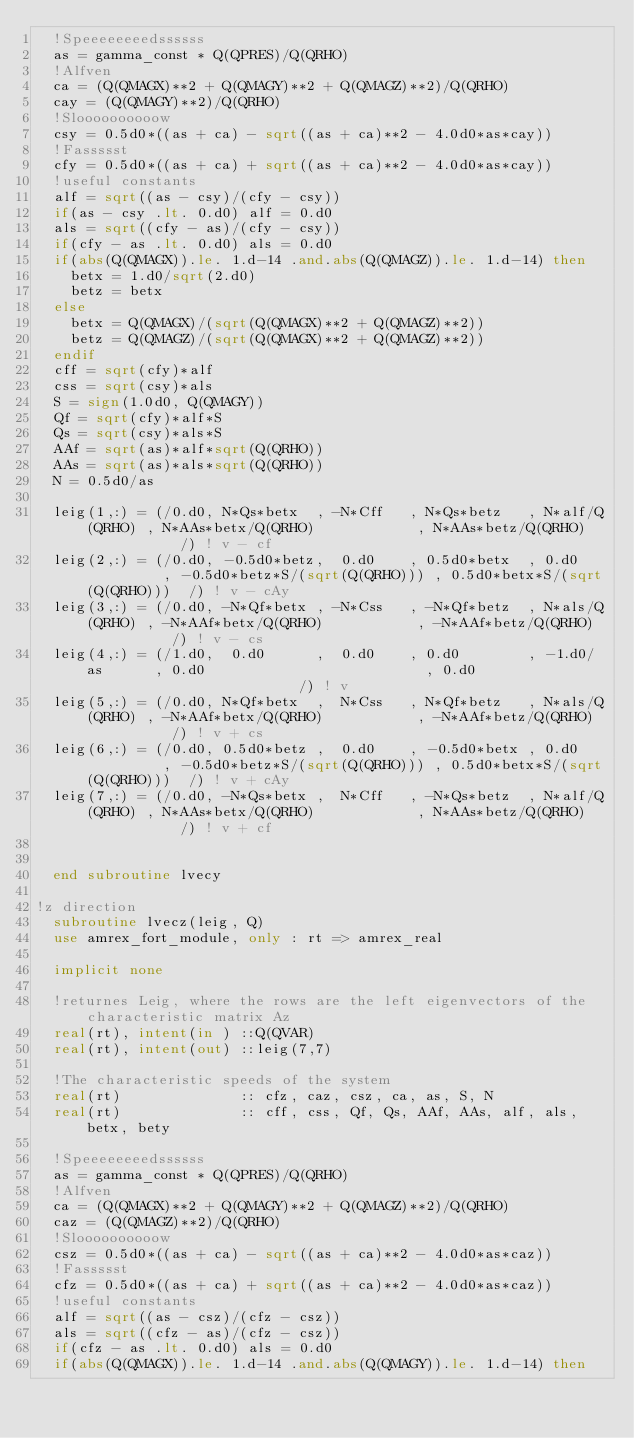Convert code to text. <code><loc_0><loc_0><loc_500><loc_500><_FORTRAN_>  !Speeeeeeeedssssss
  as = gamma_const * Q(QPRES)/Q(QRHO)
  !Alfven
  ca = (Q(QMAGX)**2 + Q(QMAGY)**2 + Q(QMAGZ)**2)/Q(QRHO)
  cay = (Q(QMAGY)**2)/Q(QRHO)
  !Sloooooooooow
  csy = 0.5d0*((as + ca) - sqrt((as + ca)**2 - 4.0d0*as*cay))
  !Fassssst
  cfy = 0.5d0*((as + ca) + sqrt((as + ca)**2 - 4.0d0*as*cay))
  !useful constants
  alf = sqrt((as - csy)/(cfy - csy))
  if(as - csy .lt. 0.d0) alf = 0.d0
  als = sqrt((cfy - as)/(cfy - csy))
  if(cfy - as .lt. 0.d0) als = 0.d0
  if(abs(Q(QMAGX)).le. 1.d-14 .and.abs(Q(QMAGZ)).le. 1.d-14) then
    betx = 1.d0/sqrt(2.d0)
    betz = betx
  else
    betx = Q(QMAGX)/(sqrt(Q(QMAGX)**2 + Q(QMAGZ)**2))
    betz = Q(QMAGZ)/(sqrt(Q(QMAGX)**2 + Q(QMAGZ)**2))
  endif
  cff = sqrt(cfy)*alf
  css = sqrt(csy)*als
  S = sign(1.0d0, Q(QMAGY))
  Qf = sqrt(cfy)*alf*S
  Qs = sqrt(csy)*als*S
  AAf = sqrt(as)*alf*sqrt(Q(QRHO))
  AAs = sqrt(as)*als*sqrt(Q(QRHO))
  N = 0.5d0/as

  leig(1,:) = (/0.d0, N*Qs*betx  , -N*Cff   , N*Qs*betz   , N*alf/Q(QRHO) , N*AAs*betx/Q(QRHO)            , N*AAs*betz/Q(QRHO)            /) ! v - cf
  leig(2,:) = (/0.d0, -0.5d0*betz,  0.d0    , 0.5d0*betx  , 0.d0          , -0.5d0*betz*S/(sqrt(Q(QRHO))) , 0.5d0*betx*S/(sqrt(Q(QRHO)))  /) ! v - cAy
  leig(3,:) = (/0.d0, -N*Qf*betx , -N*Css   , -N*Qf*betz  , N*als/Q(QRHO) , -N*AAf*betx/Q(QRHO)           , -N*AAf*betz/Q(QRHO)           /) ! v - cs
  leig(4,:) = (/1.d0,  0.d0      ,  0.d0    , 0.d0        , -1.d0/as      , 0.d0                          , 0.d0                          /) ! v 
  leig(5,:) = (/0.d0, N*Qf*betx  ,  N*Css   , N*Qf*betz   , N*als/Q(QRHO) , -N*AAf*betx/Q(QRHO)           , -N*AAf*betz/Q(QRHO)           /) ! v + cs
  leig(6,:) = (/0.d0, 0.5d0*betz ,  0.d0    , -0.5d0*betx , 0.d0          , -0.5d0*betz*S/(sqrt(Q(QRHO))) , 0.5d0*betx*S/(sqrt(Q(QRHO)))  /) ! v + cAy
  leig(7,:) = (/0.d0, -N*Qs*betx ,  N*Cff   , -N*Qs*betz  , N*alf/Q(QRHO) , N*AAs*betx/Q(QRHO)            , N*AAs*betz/Q(QRHO)            /) ! v + cf


  end subroutine lvecy

!z direction
  subroutine lvecz(leig, Q) 
  use amrex_fort_module, only : rt => amrex_real

  implicit none

  !returnes Leig, where the rows are the left eigenvectors of the characteristic matrix Az
	real(rt), intent(in ) ::Q(QVAR)
	real(rt), intent(out) ::leig(7,7)

  !The characteristic speeds of the system 
	real(rt)              :: cfz, caz, csz, ca, as, S, N
	real(rt)              :: cff, css, Qf, Qs, AAf, AAs, alf, als, betx, bety

  !Speeeeeeeedssssss
  as = gamma_const * Q(QPRES)/Q(QRHO)
  !Alfven
  ca = (Q(QMAGX)**2 + Q(QMAGY)**2 + Q(QMAGZ)**2)/Q(QRHO)
  caz = (Q(QMAGZ)**2)/Q(QRHO)
  !Sloooooooooow
  csz = 0.5d0*((as + ca) - sqrt((as + ca)**2 - 4.0d0*as*caz))
  !Fassssst
  cfz = 0.5d0*((as + ca) + sqrt((as + ca)**2 - 4.0d0*as*caz))
  !useful constants
  alf = sqrt((as - csz)/(cfz - csz))
  als = sqrt((cfz - as)/(cfz - csz))
  if(cfz - as .lt. 0.d0) als = 0.d0
  if(abs(Q(QMAGX)).le. 1.d-14 .and.abs(Q(QMAGY)).le. 1.d-14) then</code> 